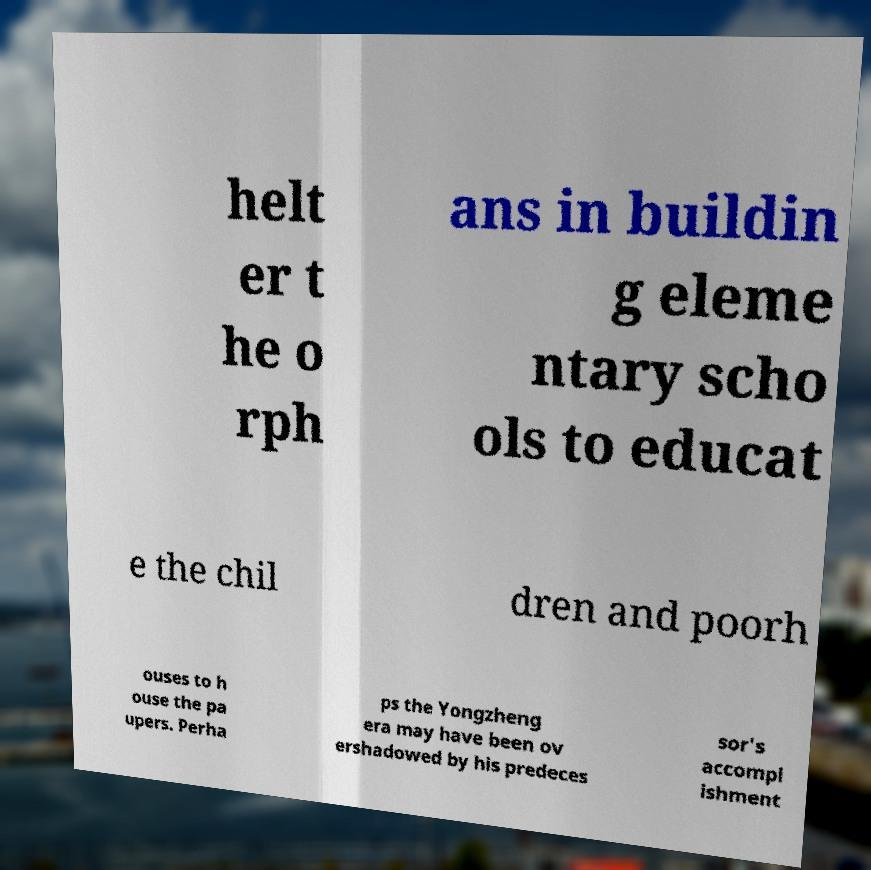For documentation purposes, I need the text within this image transcribed. Could you provide that? helt er t he o rph ans in buildin g eleme ntary scho ols to educat e the chil dren and poorh ouses to h ouse the pa upers. Perha ps the Yongzheng era may have been ov ershadowed by his predeces sor's accompl ishment 